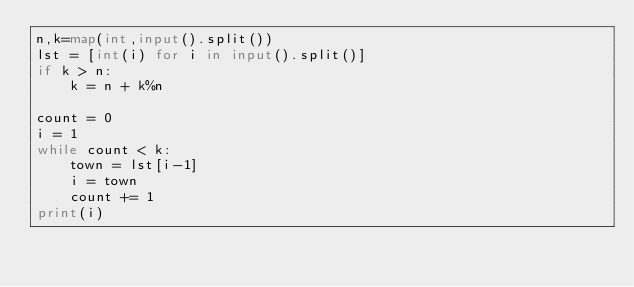<code> <loc_0><loc_0><loc_500><loc_500><_Python_>n,k=map(int,input().split())
lst = [int(i) for i in input().split()]
if k > n:
    k = n + k%n

count = 0
i = 1
while count < k:
    town = lst[i-1]
    i = town
    count += 1
print(i)</code> 